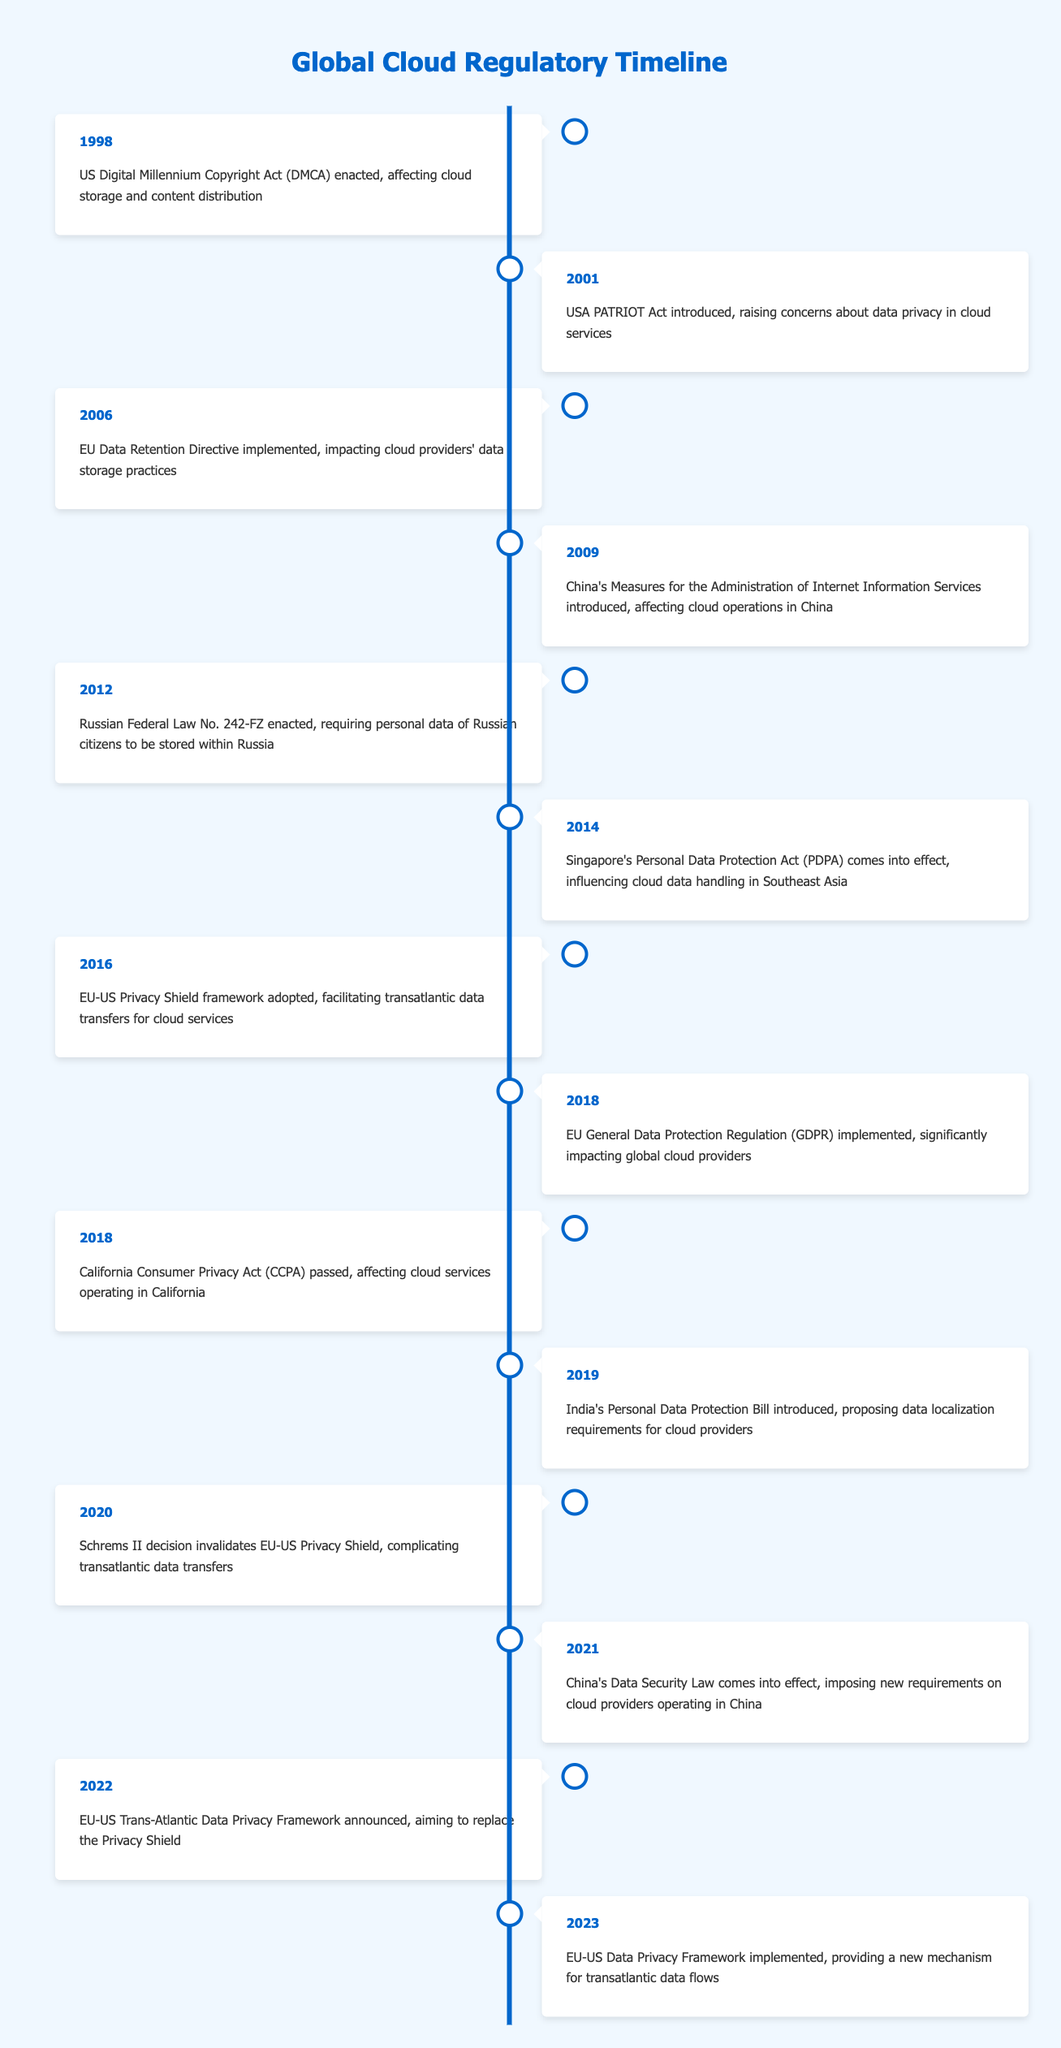What event in 2018 had a significant impact on global cloud providers? The event in 2018 that significantly impacted global cloud providers was the implementation of the EU General Data Protection Regulation (GDPR). This regulation set strict data protection and privacy rules that affected how cloud providers handle personal data across the EU and beyond.
Answer: EU General Data Protection Regulation (GDPR) implemented What year did China introduce a law that imposed new requirements on cloud providers operating within its jurisdiction? In 2021, China enacted its Data Security Law, which imposed new requirements on cloud providers operating in China, impacting their operations and data management strategies.
Answer: 2021 Which two significant privacy regulations were enacted in 2018? In 2018, two significant privacy regulations were enacted: the EU General Data Protection Regulation (GDPR) and the California Consumer Privacy Act (CCPA). These regulations addressed data privacy rights and had wide-ranging effects on cloud services.
Answer: EU General Data Protection Regulation (GDPR) and California Consumer Privacy Act (CCPA) How many events in the timeline address data privacy regulations specifically? By reviewing the timeline, we can see that there are 5 events that specifically address data privacy regulations: the USA PATRIOT Act (2001), EU-US Privacy Shield (2016), EU General Data Protection Regulation (GDPR) (2018), California Consumer Privacy Act (CCPA) (2018), and China's Data Security Law (2021). This indicates a significant focus on data privacy in cloud regulation.
Answer: 5 Is the implementation of the EU-US Privacy Shield framework still in effect as of 2023? No, the EU-US Privacy Shield framework was invalidated by the Schrems II decision in 2020. While a new mechanism, the EU-US Data Privacy Framework, was implemented in 2023, this means the previous framework is no longer in effect.
Answer: No What were the implications of the EU Data Retention Directive for cloud providers? The EU Data Retention Directive implemented in 2006 had significant implications for cloud providers, as it mandated that service providers retain user data for a certain period to aid in law enforcement and national security investigations. This affected how cloud providers managed data storage and compliance operations.
Answer: Mandated data retention for law enforcement What is the difference in years between the enactment of the US Digital Millennium Copyright Act and the implementation of the EU General Data Protection Regulation? The US Digital Millennium Copyright Act was enacted in 1998, and the EU General Data Protection Regulation was implemented in 2018. Therefore, the difference is 20 years (2018 - 1998 = 20).
Answer: 20 years Which event directly resulted from a court decision regarding the EU-US Privacy Shield? The event that directly resulted from a court decision regarding the EU-US Privacy Shield was the Schrems II decision in 2020, which invalidated the framework and led to the creation of the new EU-US Data Privacy Framework announced in 2022.
Answer: Schrems II decision invalidated EU-US Privacy Shield What major change did the California Consumer Privacy Act of 2018 introduce for cloud services? The California Consumer Privacy Act (CCPA) introduced significant requirements for cloud services operating in California, including greater transparency in data collection practices and stronger privacy rights for consumers. This legislation aimed to protect consumer data and privacy within the state.
Answer: Greater transparency and consumer privacy rights 